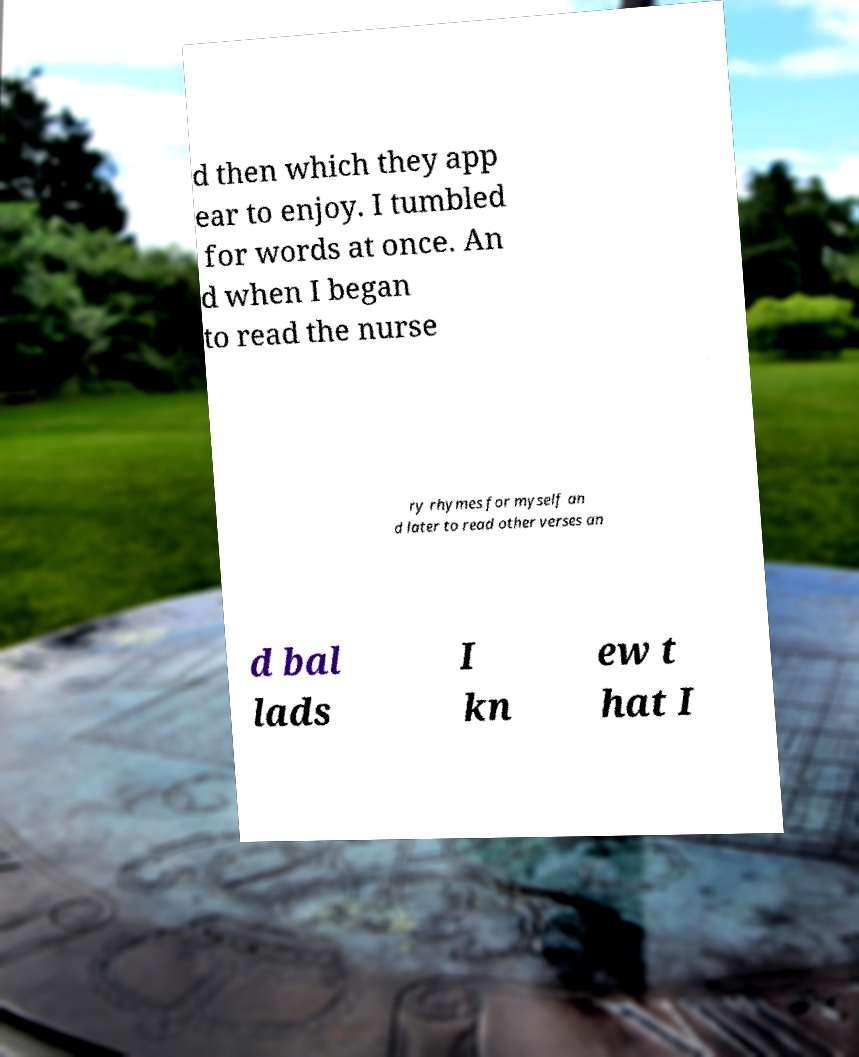There's text embedded in this image that I need extracted. Can you transcribe it verbatim? d then which they app ear to enjoy. I tumbled for words at once. An d when I began to read the nurse ry rhymes for myself an d later to read other verses an d bal lads I kn ew t hat I 